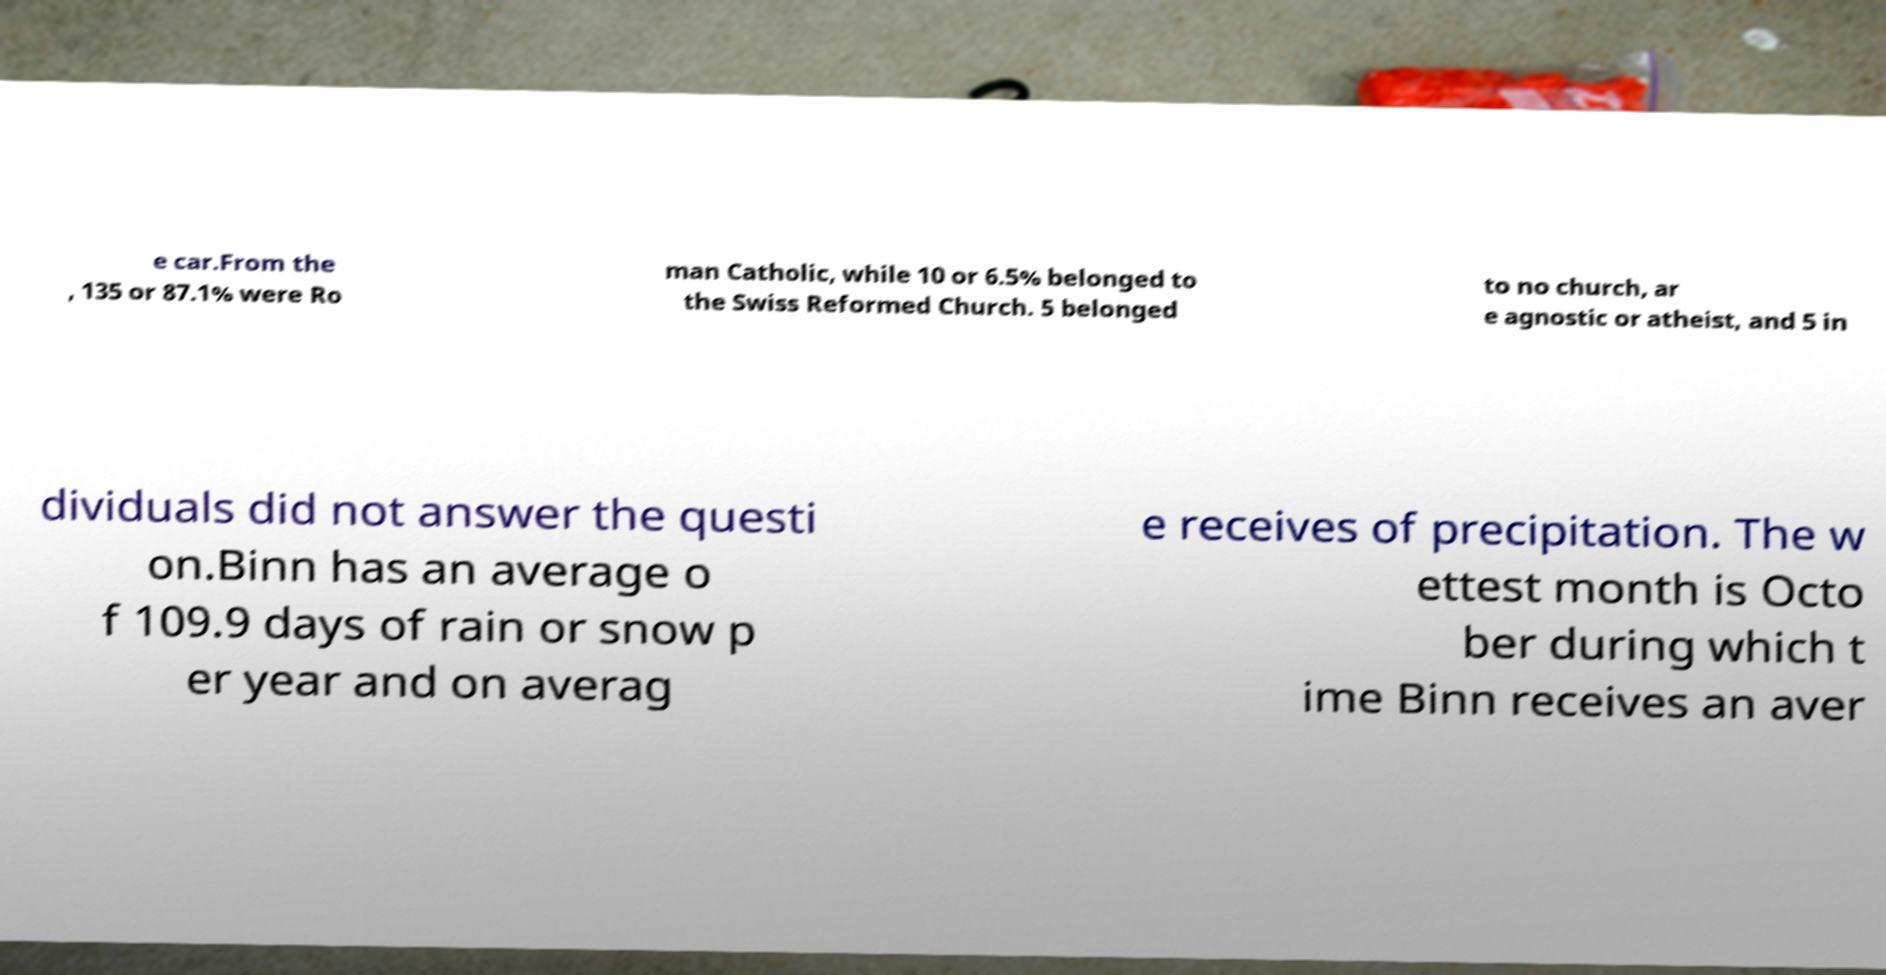There's text embedded in this image that I need extracted. Can you transcribe it verbatim? e car.From the , 135 or 87.1% were Ro man Catholic, while 10 or 6.5% belonged to the Swiss Reformed Church. 5 belonged to no church, ar e agnostic or atheist, and 5 in dividuals did not answer the questi on.Binn has an average o f 109.9 days of rain or snow p er year and on averag e receives of precipitation. The w ettest month is Octo ber during which t ime Binn receives an aver 